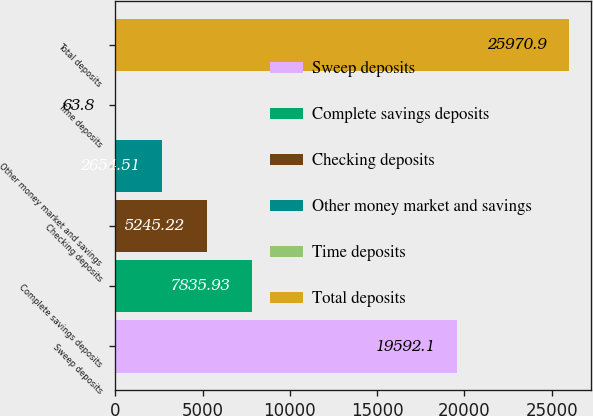Convert chart to OTSL. <chart><loc_0><loc_0><loc_500><loc_500><bar_chart><fcel>Sweep deposits<fcel>Complete savings deposits<fcel>Checking deposits<fcel>Other money market and savings<fcel>Time deposits<fcel>Total deposits<nl><fcel>19592.1<fcel>7835.93<fcel>5245.22<fcel>2654.51<fcel>63.8<fcel>25970.9<nl></chart> 